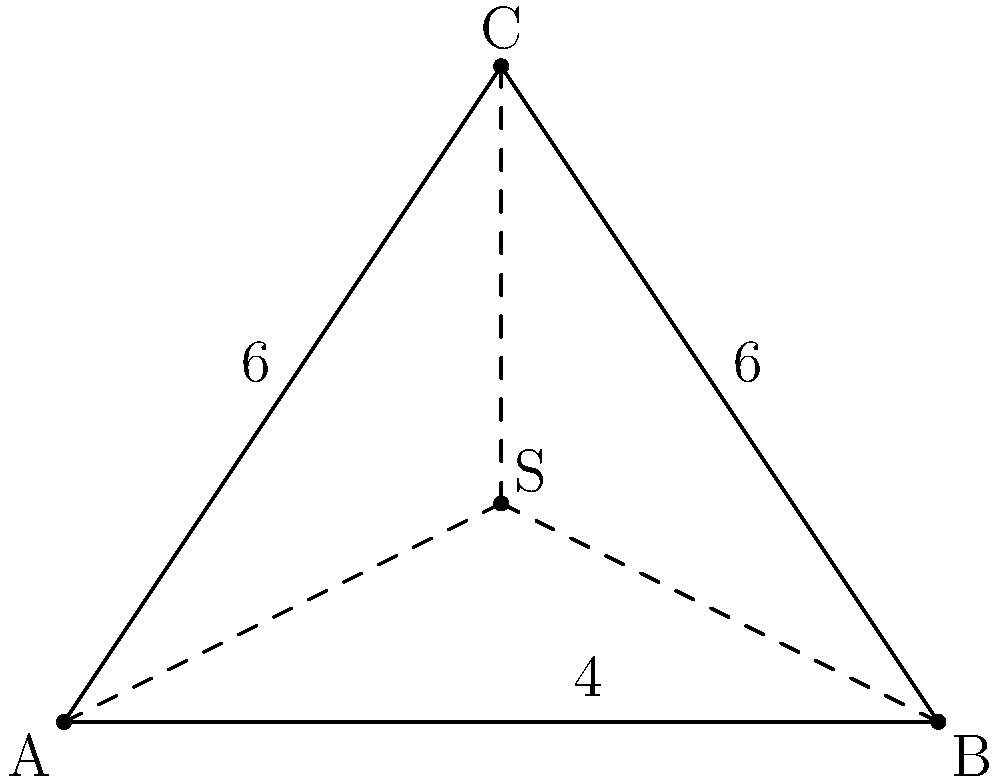In a municipal complex, three buildings A, B, and C form a triangle. The distances between the buildings are: AB = 8 units, AC = 6 units, and BC = 6 units. To minimize the total length of underground utility lines connecting all three buildings, a central connection point S needs to be determined. What are the coordinates of point S that minimize the total length of AS + BS + CS? To find the optimal location of point S, we can use the concept of the Fermat point (also known as the Torricelli point) in a triangle. For a triangle where all angles are less than 120°, the Fermat point minimizes the sum of distances to all three vertices.

Step 1: Check if all angles in the triangle are less than 120°.
We can use the cosine law to calculate the angles:
$\cos A = \frac{b^2 + c^2 - a^2}{2bc} = \frac{6^2 + 8^2 - 6^2}{2 \cdot 6 \cdot 8} = \frac{64}{96} = \frac{2}{3}$
$A = \arccos(\frac{2}{3}) \approx 48.2°$

Similarly, we can calculate B and C:
$B \approx 65.9°$ and $C \approx 65.9°$

All angles are indeed less than 120°, so the Fermat point exists.

Step 2: Determine the coordinates of the triangle vertices.
We can place A at (0,0), B at (8,0), and calculate C's coordinates:
$C_x = 4$ (midpoint of AB)
$C_y = \sqrt{6^2 - 4^2} = \sqrt{20} \approx 4.47$

For simplicity, we'll use C(4,6) as an approximation.

Step 3: Calculate the coordinates of the Fermat point S.
The coordinates of S can be calculated using the following formulas:

$S_x = \frac{a(p-a)x_1 + b(p-b)x_2 + c(p-c)x_3}{a(p-a) + b(p-b) + c(p-c)}$

$S_y = \frac{a(p-a)y_1 + b(p-b)y_2 + c(p-c)y_3}{a(p-a) + b(p-b) + c(p-c)}$

Where:
$a$, $b$, and $c$ are the side lengths of the triangle
$p = \frac{a+b+c}{2}$ is the semi-perimeter
$(x_1,y_1)$, $(x_2,y_2)$, and $(x_3,y_3)$ are the coordinates of A, B, and C respectively

Calculating:
$p = \frac{8+6+6}{2} = 10$

$S_x = \frac{8(10-8)0 + 6(10-6)8 + 6(10-6)4}{8(10-8) + 6(10-6) + 6(10-6)} = \frac{192+96}{16+24+24} = \frac{288}{64} = 4.5$

$S_y = \frac{8(10-8)0 + 6(10-6)0 + 6(10-6)6}{8(10-8) + 6(10-6) + 6(10-6)} = \frac{144}{64} = 2.25$

Therefore, the coordinates of point S are approximately (4.5, 2.25).
Answer: (4.5, 2.25) 